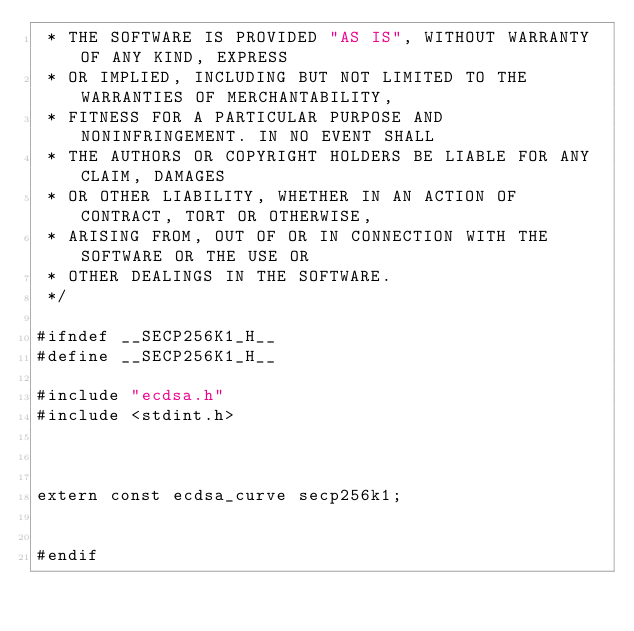Convert code to text. <code><loc_0><loc_0><loc_500><loc_500><_C_> * THE SOFTWARE IS PROVIDED "AS IS", WITHOUT WARRANTY OF ANY KIND, EXPRESS
 * OR IMPLIED, INCLUDING BUT NOT LIMITED TO THE WARRANTIES OF MERCHANTABILITY,
 * FITNESS FOR A PARTICULAR PURPOSE AND NONINFRINGEMENT. IN NO EVENT SHALL
 * THE AUTHORS OR COPYRIGHT HOLDERS BE LIABLE FOR ANY CLAIM, DAMAGES
 * OR OTHER LIABILITY, WHETHER IN AN ACTION OF CONTRACT, TORT OR OTHERWISE,
 * ARISING FROM, OUT OF OR IN CONNECTION WITH THE SOFTWARE OR THE USE OR
 * OTHER DEALINGS IN THE SOFTWARE.
 */

#ifndef __SECP256K1_H__
#define __SECP256K1_H__

#include "ecdsa.h"
#include <stdint.h>



extern const ecdsa_curve secp256k1;


#endif
</code> 